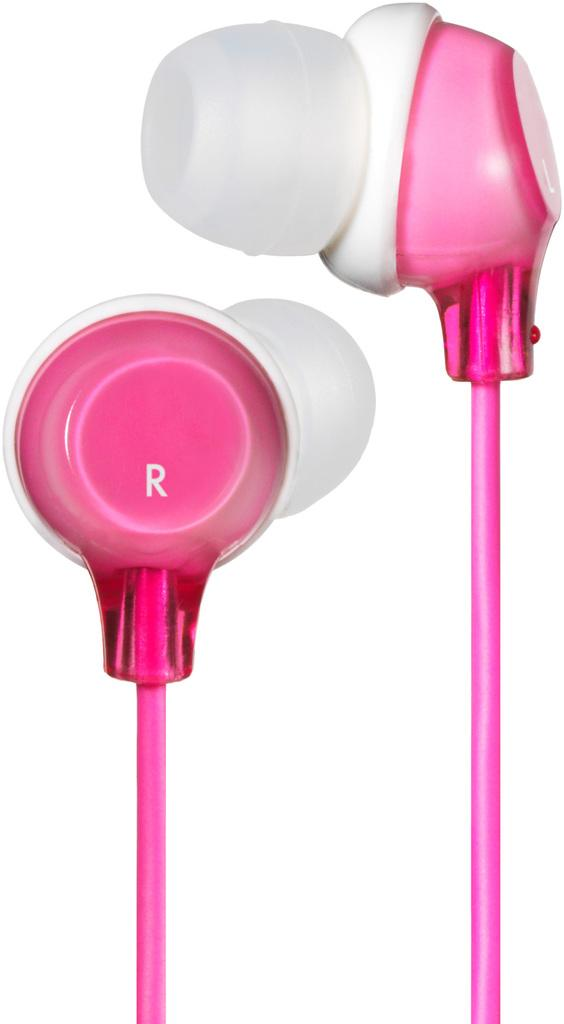What objects are present in the image? There are two headset buds in the image. What is the color of the headset buds? The headset buds are pink in color. What grade did the cake receive for its polish in the image? There is no cake or mention of polish in the image. 